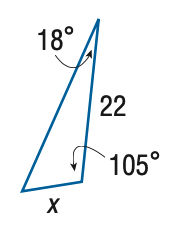Question: Find x. Round side measure to the nearest tenth.
Choices:
A. 7.0
B. 8.1
C. 59.7
D. 68.8
Answer with the letter. Answer: B 